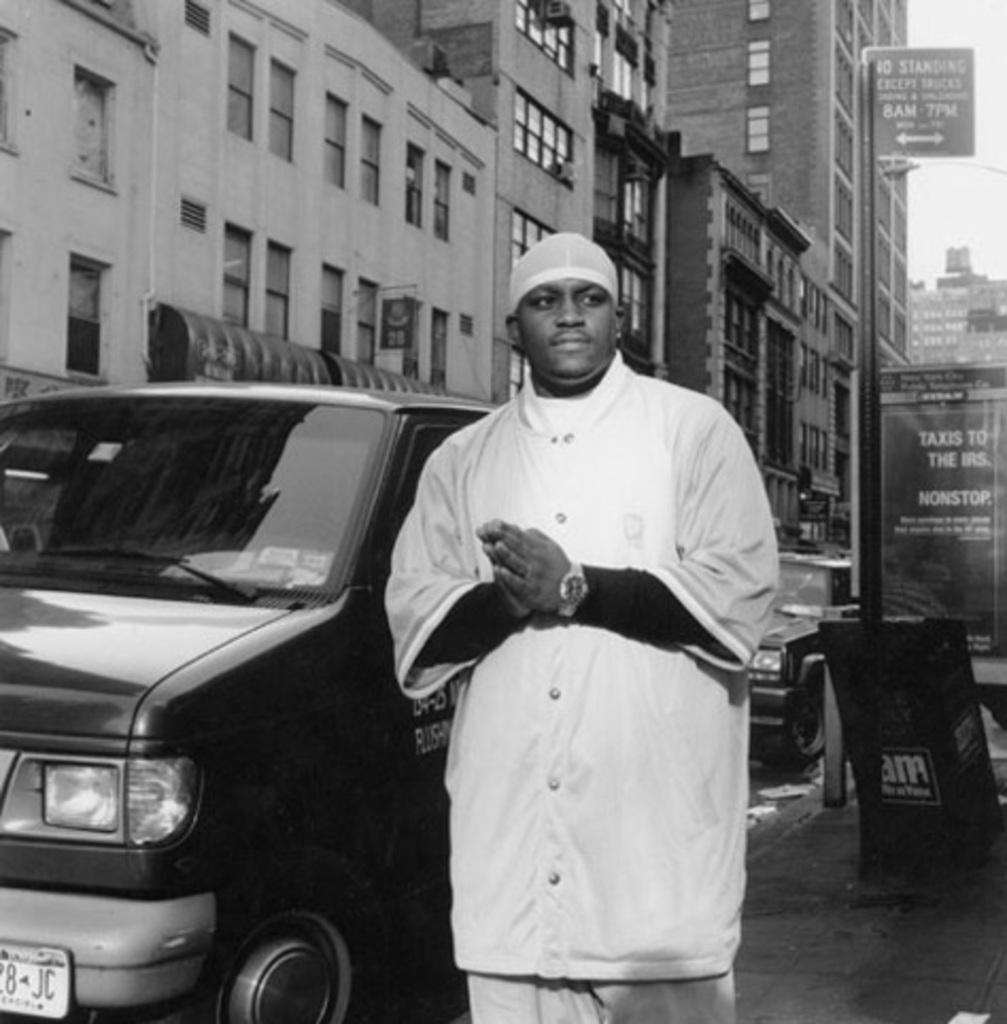What does the liscense plate say?
Offer a very short reply. 8 jc. 